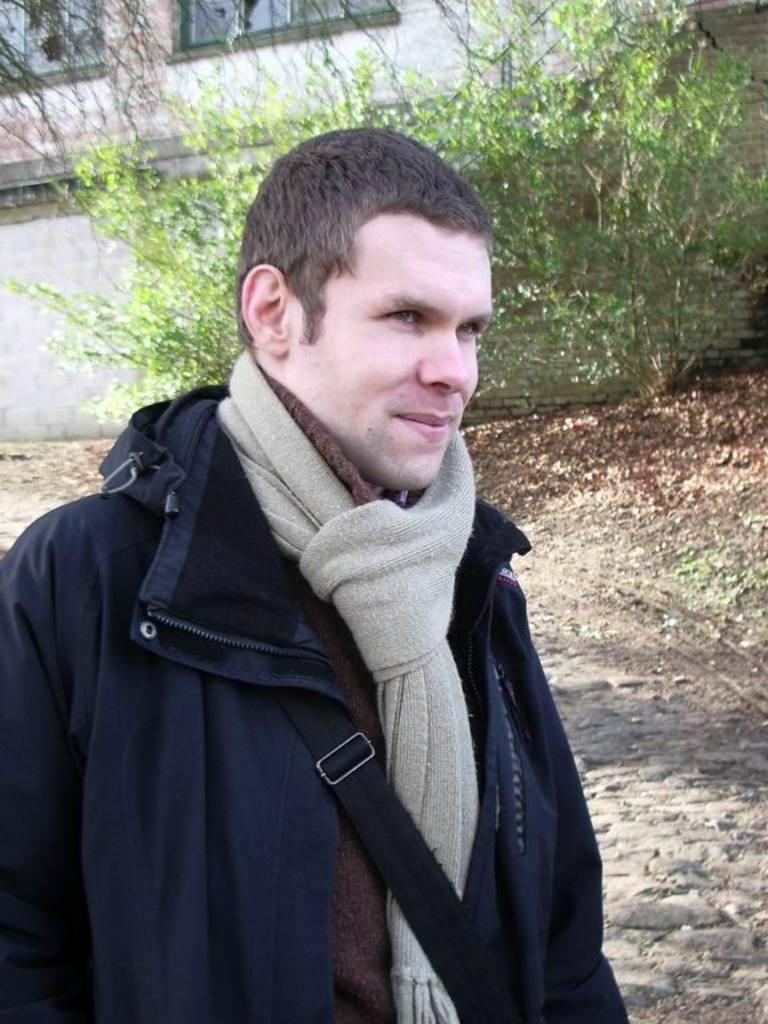Can you describe this image briefly? In this image we can see a person. Behind the person we can see a wall of a building and a few plants. In the top left, we can see the windows. 